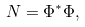Convert formula to latex. <formula><loc_0><loc_0><loc_500><loc_500>N = \Phi ^ { * } \Phi ,</formula> 